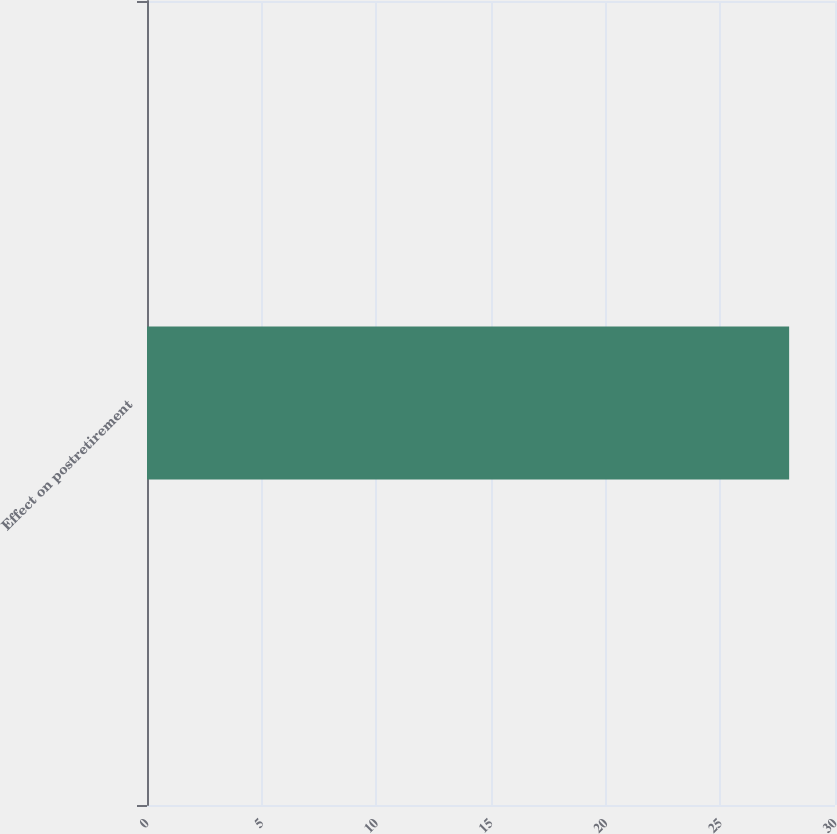<chart> <loc_0><loc_0><loc_500><loc_500><bar_chart><fcel>Effect on postretirement<nl><fcel>28<nl></chart> 